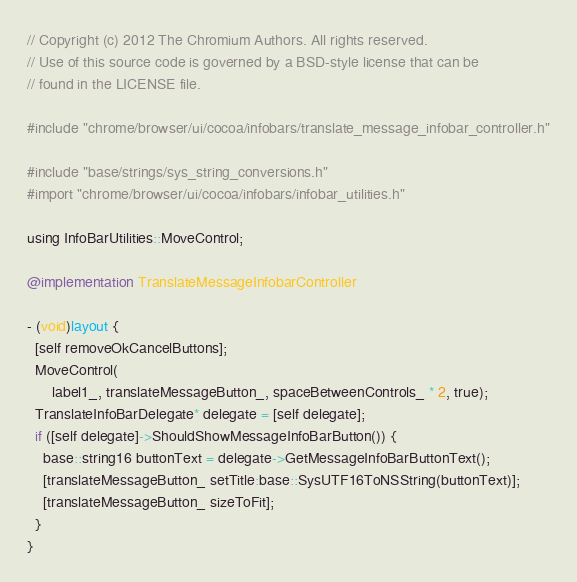<code> <loc_0><loc_0><loc_500><loc_500><_ObjectiveC_>// Copyright (c) 2012 The Chromium Authors. All rights reserved.
// Use of this source code is governed by a BSD-style license that can be
// found in the LICENSE file.

#include "chrome/browser/ui/cocoa/infobars/translate_message_infobar_controller.h"

#include "base/strings/sys_string_conversions.h"
#import "chrome/browser/ui/cocoa/infobars/infobar_utilities.h"

using InfoBarUtilities::MoveControl;

@implementation TranslateMessageInfobarController

- (void)layout {
  [self removeOkCancelButtons];
  MoveControl(
      label1_, translateMessageButton_, spaceBetweenControls_ * 2, true);
  TranslateInfoBarDelegate* delegate = [self delegate];
  if ([self delegate]->ShouldShowMessageInfoBarButton()) {
    base::string16 buttonText = delegate->GetMessageInfoBarButtonText();
    [translateMessageButton_ setTitle:base::SysUTF16ToNSString(buttonText)];
    [translateMessageButton_ sizeToFit];
  }
}
</code> 